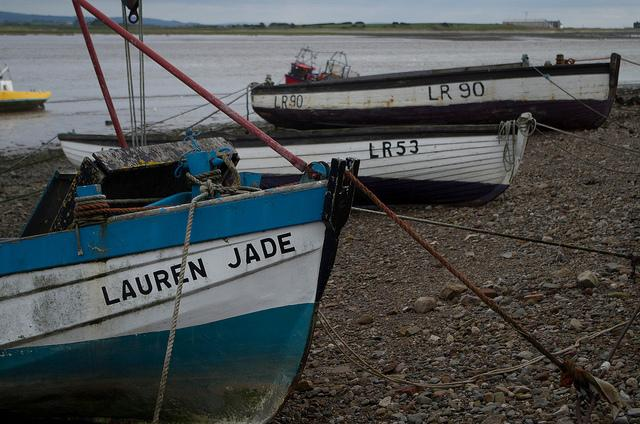What celebrity first name appears on the boat?

Choices:
A) idris elba
B) jim duggan
C) tony atlas
D) lauren cohan lauren cohan 